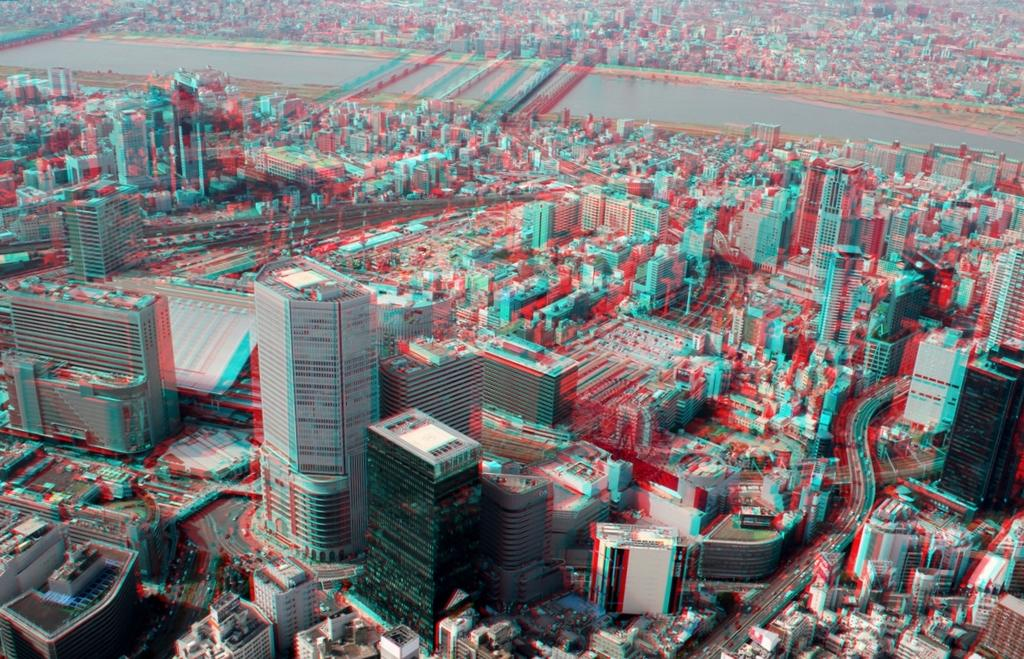What type of structures can be seen in the image? There are many buildings in the image. What is moving on the roads in the image? There are vehicles on the roads in the image. What natural element is visible in the image? There is water visible in the image. What is the title of the baby's favorite book in the image? There is no baby or book present in the image, so it is not possible to determine the title of a favorite book. 